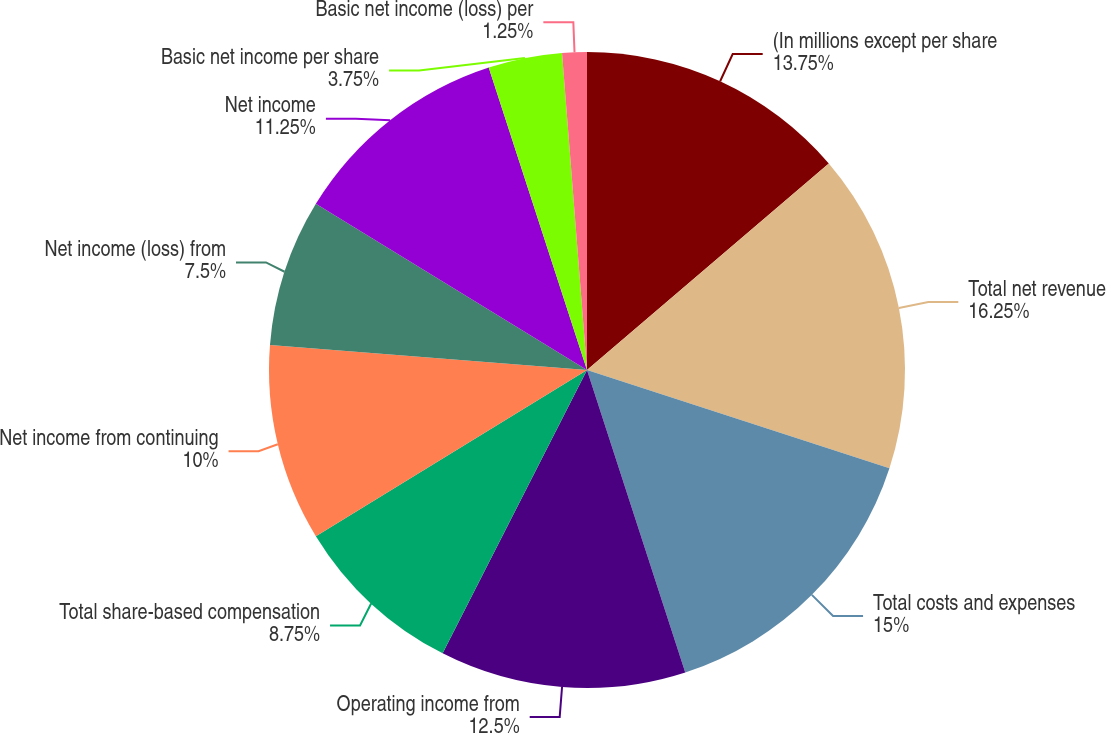Convert chart to OTSL. <chart><loc_0><loc_0><loc_500><loc_500><pie_chart><fcel>(In millions except per share<fcel>Total net revenue<fcel>Total costs and expenses<fcel>Operating income from<fcel>Total share-based compensation<fcel>Net income from continuing<fcel>Net income (loss) from<fcel>Net income<fcel>Basic net income per share<fcel>Basic net income (loss) per<nl><fcel>13.75%<fcel>16.25%<fcel>15.0%<fcel>12.5%<fcel>8.75%<fcel>10.0%<fcel>7.5%<fcel>11.25%<fcel>3.75%<fcel>1.25%<nl></chart> 